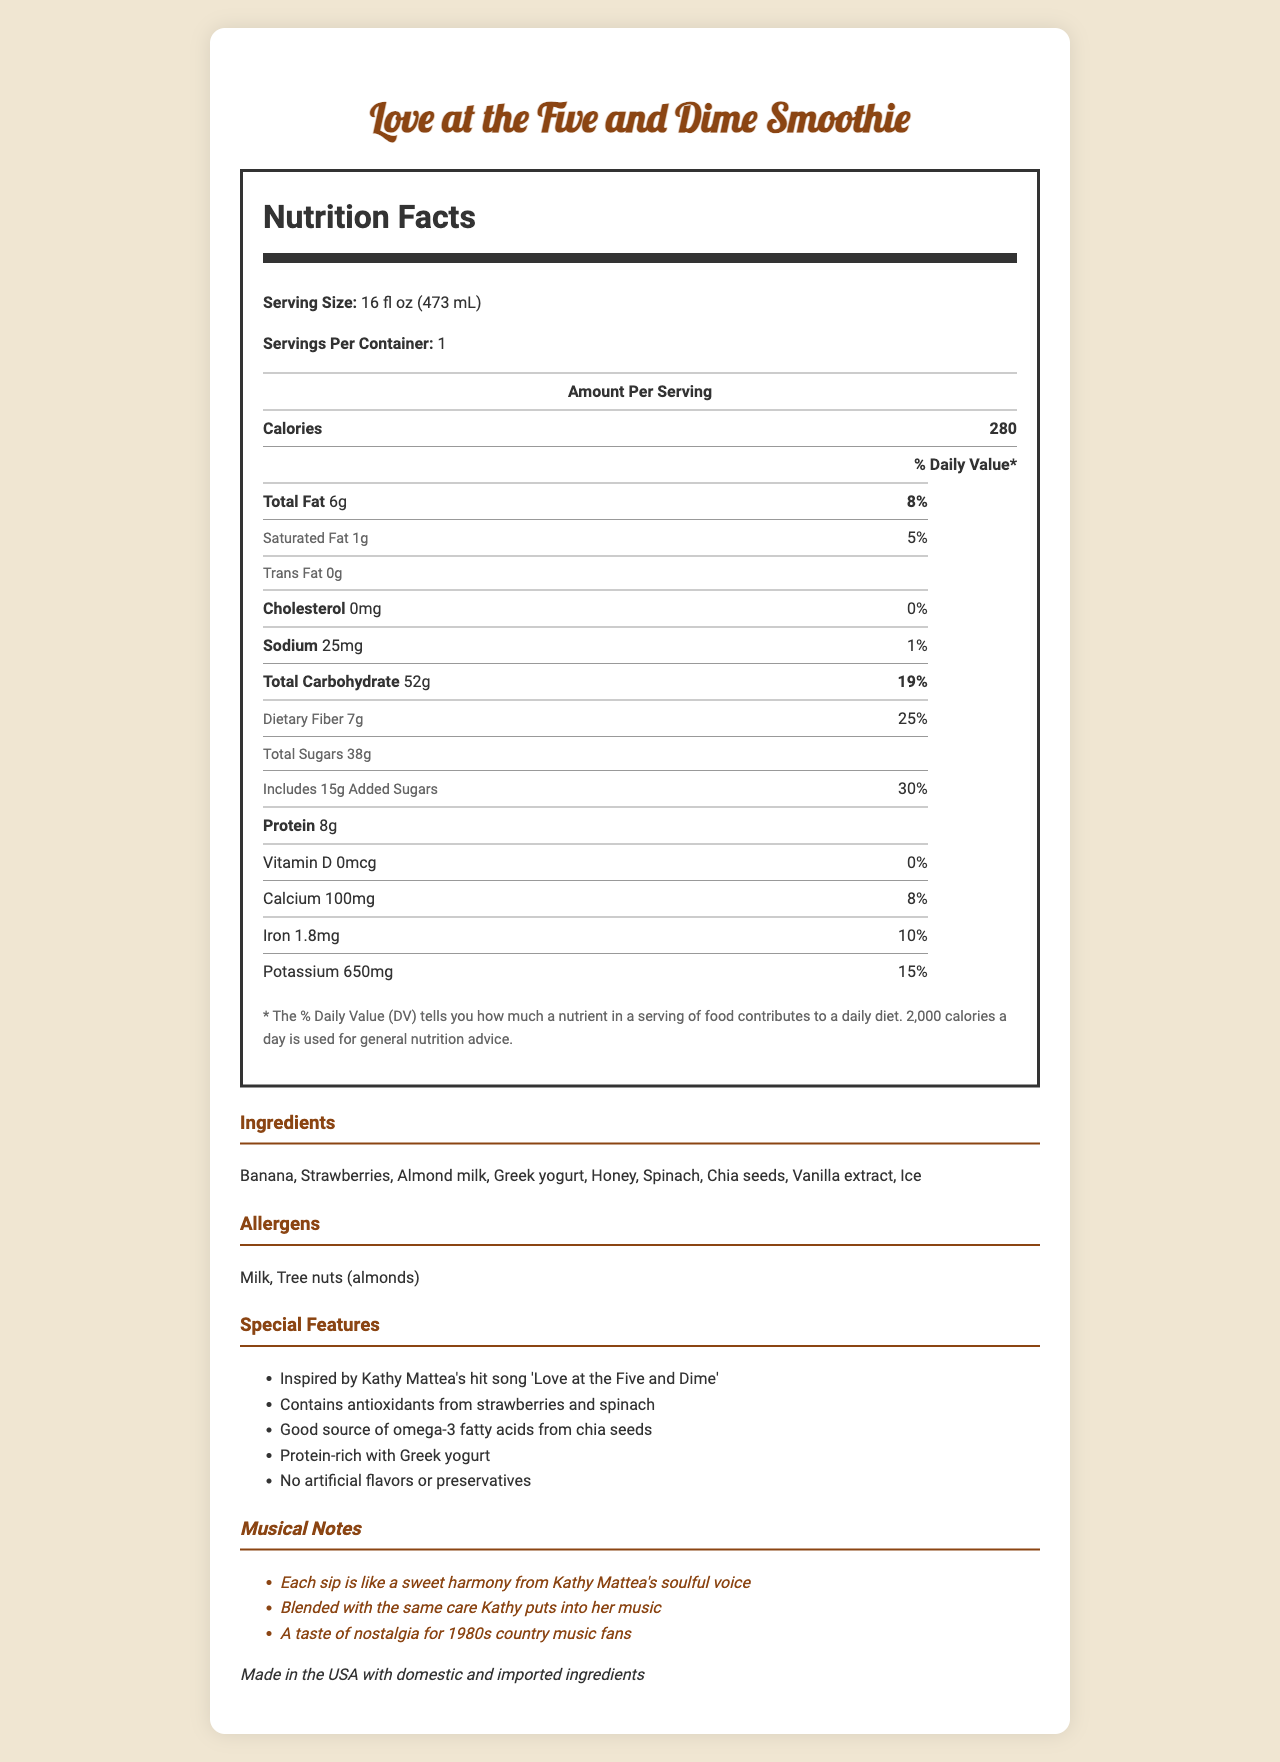what is the serving size for the Love at the Five and Dime smoothie? The document specifies the serving size under the Nutrition Facts section as 16 fl oz (473 mL).
Answer: 16 fl oz (473 mL) how many calories are in one serving of the smoothie? The document lists the calories per serving as 280.
Answer: 280 how much protein does the smoothie contain per serving? The amount of protein per serving is mentioned in the Nutrition Facts table as 8g.
Answer: 8g which vitamins and minerals are highlighted in the nutrition facts? The vitamins and minerals are listed under the Nutrition Facts section: Vitamin D (0mcg), Calcium (100mg), Iron (1.8mg), and Potassium (650mg).
Answer: Vitamin D, Calcium, Iron, Potassium what allergens are present in the smoothie? The allergens section lists Milk and Tree nuts (almonds).
Answer: Milk, Tree nuts (almonds) what are the primary ingredients in the smoothie? The ingredients section lists all the primary components that make up the smoothie.
Answer: Banana, Strawberries, Almond milk, Greek yogurt, Honey, Spinach, Chia seeds, Vanilla extract, Ice which nutrient has the highest daily value percentage? The document highlights that the added sugars amount to 30% of the daily value, which is the highest percentage listed.
Answer: Added Sugars (30%) what is the purpose of chia seeds in the smoothie? A. To add flavor B. To provide antioxidants C. To enrich with omega-3 fatty acids D. To increase carbohydrate content The special features section states that chia seeds are a good source of omega-3 fatty acids.
Answer: C how does the smoothie relate to music? A. It can be consumed at concerts B. It is inspired by Kathy Mattea's song C. It is featured in music videos D. It is consumed by famous musicians The document mentions that the smoothie is inspired by Kathy Mattea's hit song 'Love at the Five and Dime'.
Answer: B is there any cholesterol in the smoothie? The Nutrition Facts section specifies that the cholesterol amount is 0mg, indicating that there is no cholesterol present.
Answer: No summarize the main features and content of the document. This detailed response encompasses the key elements and unique aspects of the smoothie as described in the document, highlighting nutritional information, ingredients, allergen warnings, and the musical inspiration behind the product.
Answer: The document provides comprehensive details about the "Love at the Five and Dime" inspired smoothie, including its nutritional facts, ingredients, allergens, special features, and musical notes. It describes the smoothie as having 280 calories per 16 fl oz serving, with significant amounts of fiber, protein, and added sugars. The smoothie contains natural ingredients like banana, strawberries, and Greek yogurt, with chia seeds providing omega-3 fatty acids. It is designed to evoke nostalgia for Kathy Mattea's music, particularly her song 'Love at the Five and Dime'. what is the total carbohydrate content excluding dietary fiber and sugars? The document provides total carbohydrate content, dietary fiber, and total sugars but does not give the exact amounts needed to calculate carbohydrates excluding fiber and sugars.
Answer: Not enough information 